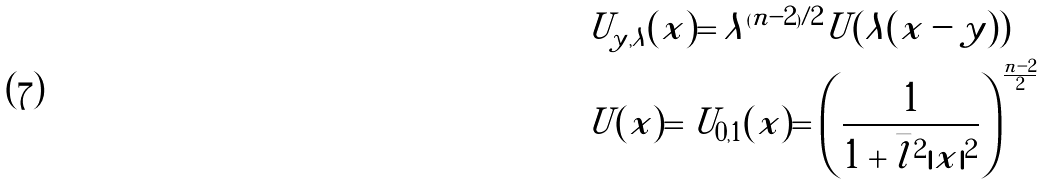<formula> <loc_0><loc_0><loc_500><loc_500>& U _ { y , \lambda } ( x ) = \lambda ^ { ( n - 2 ) / 2 } U ( \lambda ( x - y ) ) \\ & U ( x ) = U _ { 0 , 1 } ( x ) = \left ( \frac { 1 } { 1 + \bar { l } ^ { 2 } | x | ^ { 2 } } \right ) ^ { \frac { n - 2 } { 2 } }</formula> 